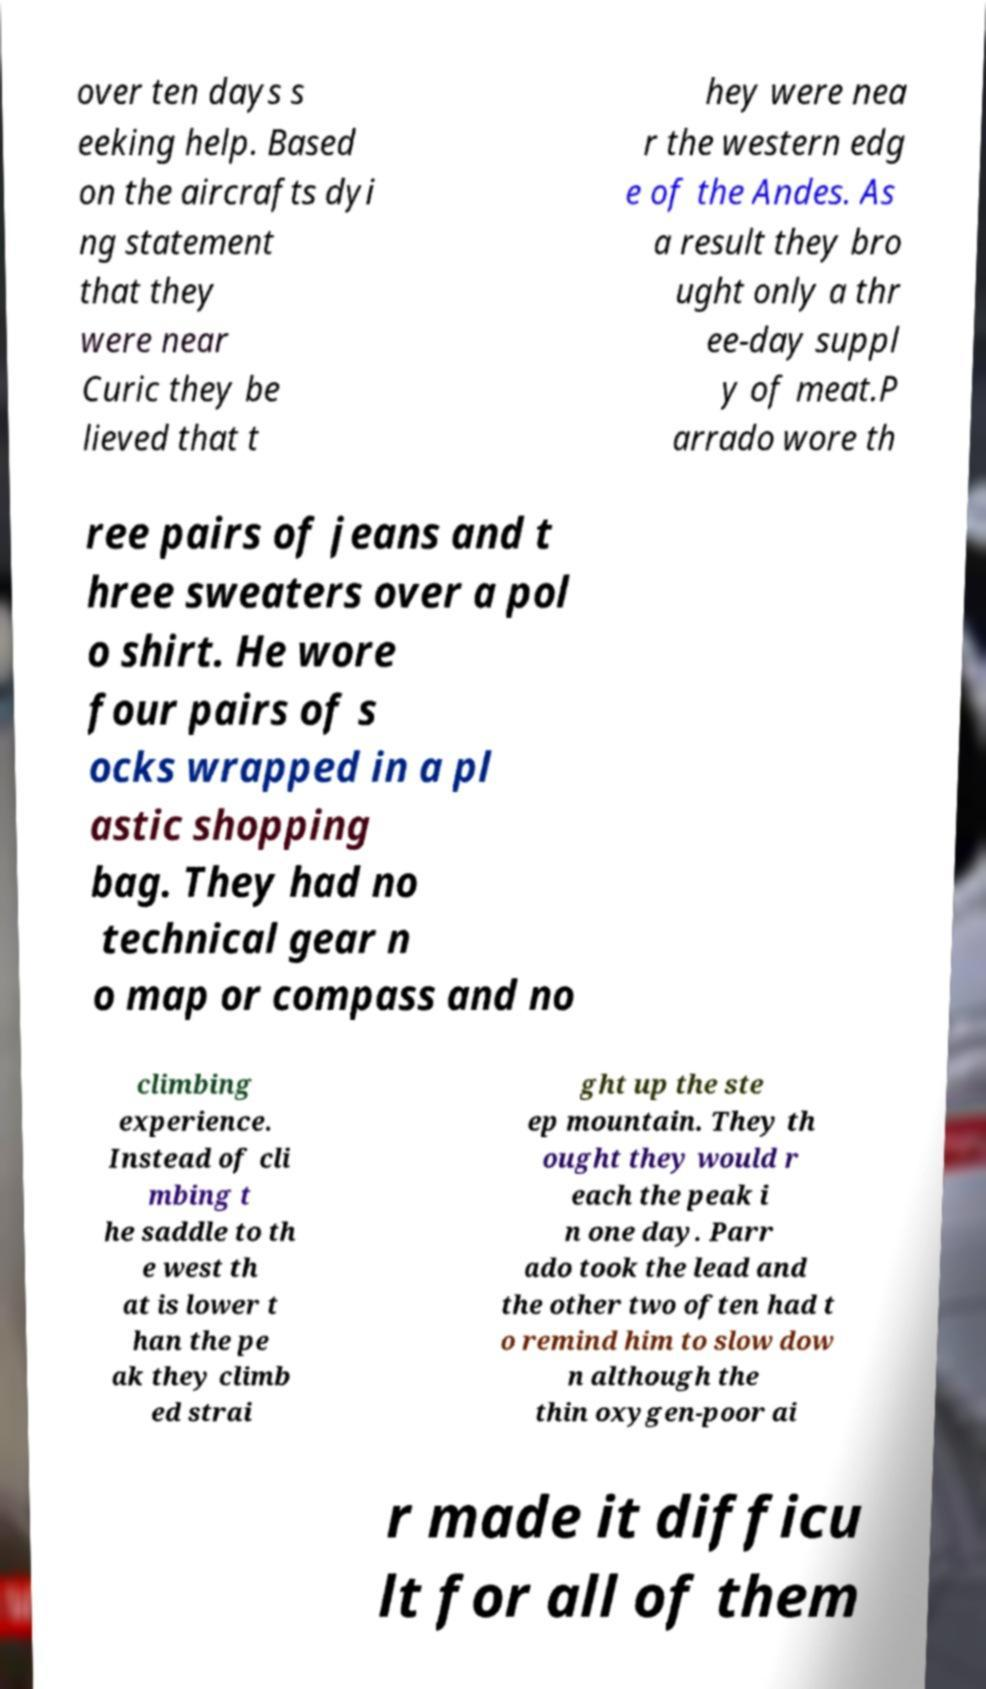Please identify and transcribe the text found in this image. over ten days s eeking help. Based on the aircrafts dyi ng statement that they were near Curic they be lieved that t hey were nea r the western edg e of the Andes. As a result they bro ught only a thr ee-day suppl y of meat.P arrado wore th ree pairs of jeans and t hree sweaters over a pol o shirt. He wore four pairs of s ocks wrapped in a pl astic shopping bag. They had no technical gear n o map or compass and no climbing experience. Instead of cli mbing t he saddle to th e west th at is lower t han the pe ak they climb ed strai ght up the ste ep mountain. They th ought they would r each the peak i n one day. Parr ado took the lead and the other two often had t o remind him to slow dow n although the thin oxygen-poor ai r made it difficu lt for all of them 